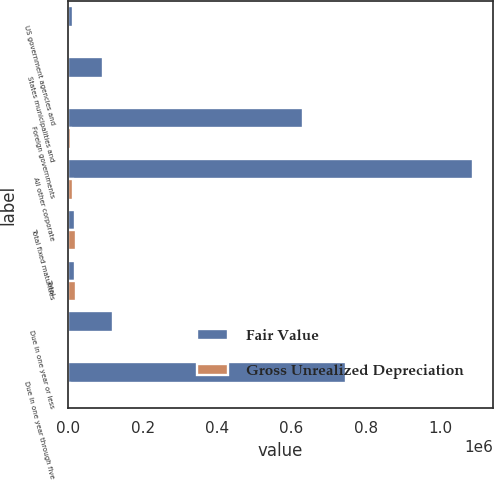Convert chart to OTSL. <chart><loc_0><loc_0><loc_500><loc_500><stacked_bar_chart><ecel><fcel>US government agencies and<fcel>States municipalities and<fcel>Foreign governments<fcel>All other corporate<fcel>Total fixed maturities<fcel>Total<fcel>Due in one year or less<fcel>Due in one year through five<nl><fcel>Fair Value<fcel>13150<fcel>94242<fcel>631035<fcel>1.0874e+06<fcel>18009.5<fcel>18009.5<fcel>121653<fcel>745692<nl><fcel>Gross Unrealized Depreciation<fcel>39<fcel>363<fcel>7293<fcel>14162<fcel>21857<fcel>21857<fcel>492<fcel>5200<nl></chart> 